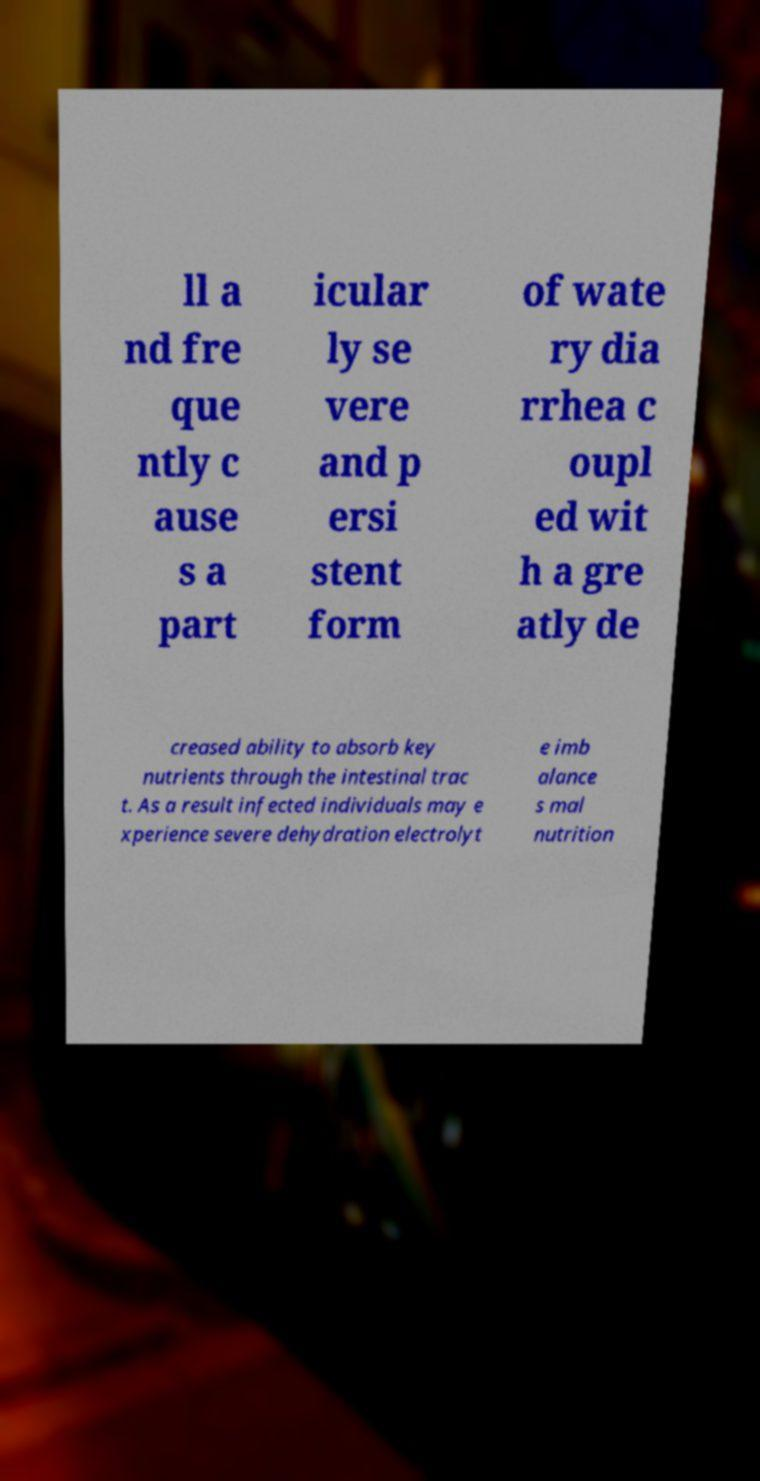Can you accurately transcribe the text from the provided image for me? ll a nd fre que ntly c ause s a part icular ly se vere and p ersi stent form of wate ry dia rrhea c oupl ed wit h a gre atly de creased ability to absorb key nutrients through the intestinal trac t. As a result infected individuals may e xperience severe dehydration electrolyt e imb alance s mal nutrition 